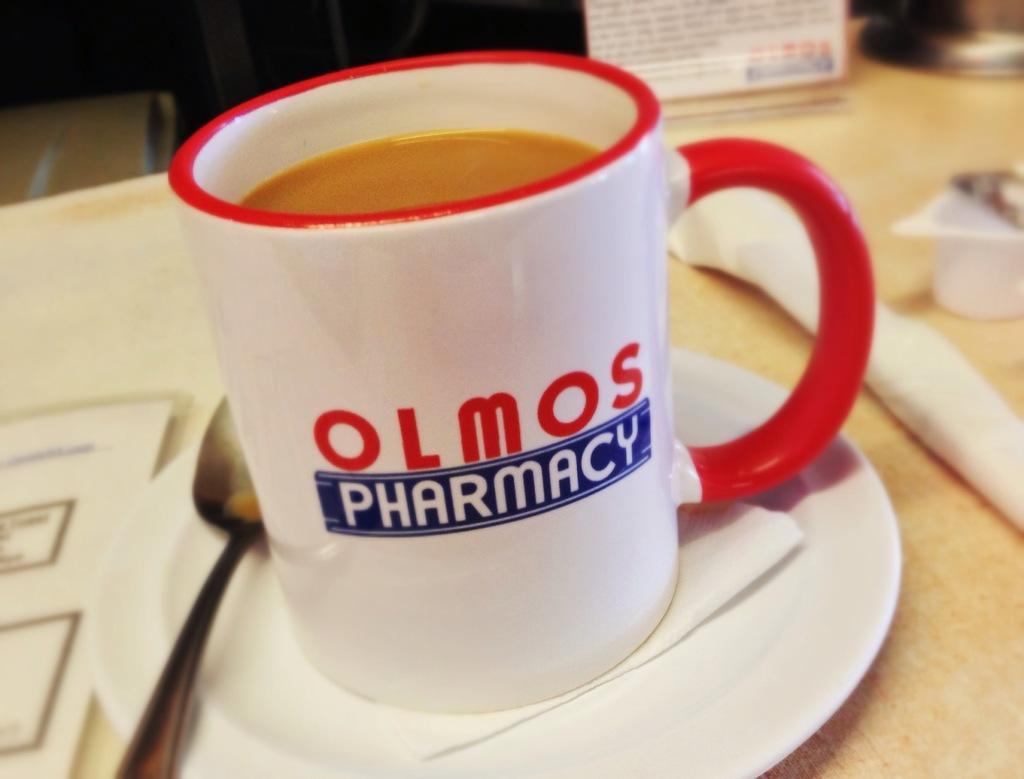Could you give a brief overview of what you see in this image? In this image I can see a white colour plate, a spoon and a white colour mug. In the mug I can see brown colour thing. On the right of this image I can see few white colour things, a white colour board and on it I can see something is written. I can also see a paper on the bottom left side of this image and on the mug I can see something is written. 